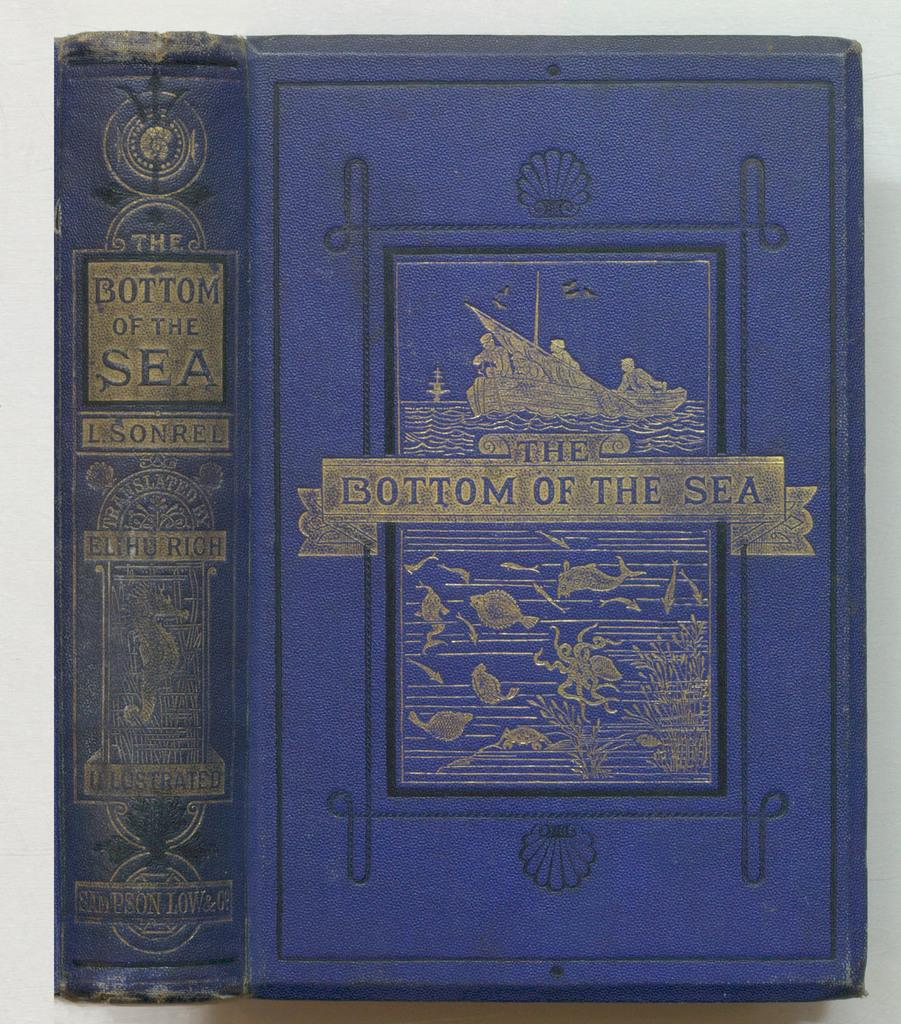Provide a one-sentence caption for the provided image. a blue book with the bottom of the sea written on it. 